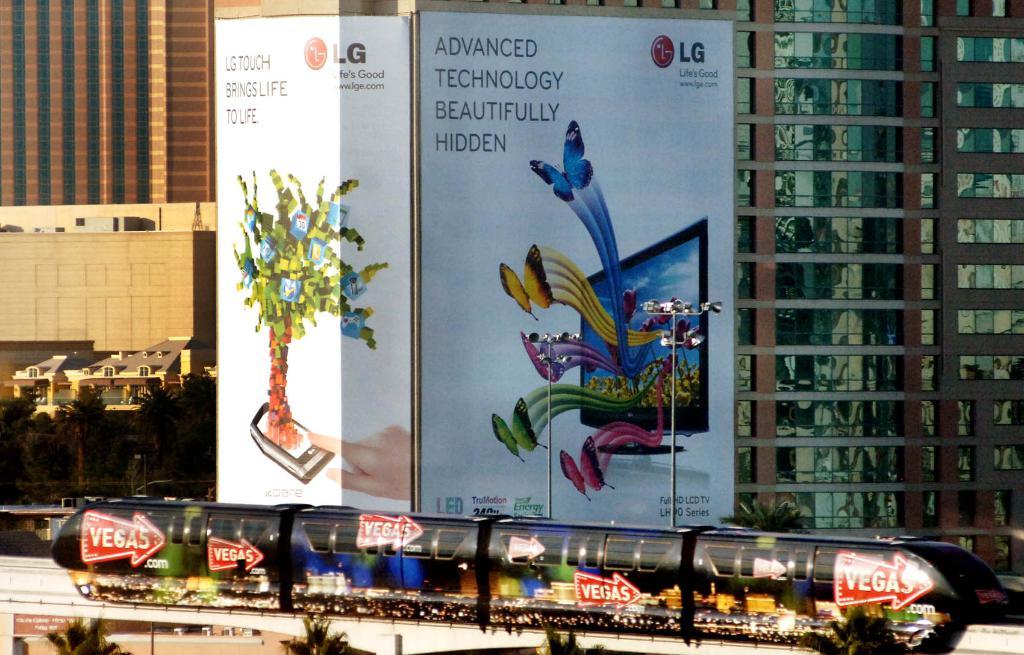Which city is the train pointing to?
Your answer should be compact. Vegas. What is the company that sponsored this add on the building/?
Give a very brief answer. Lg. 